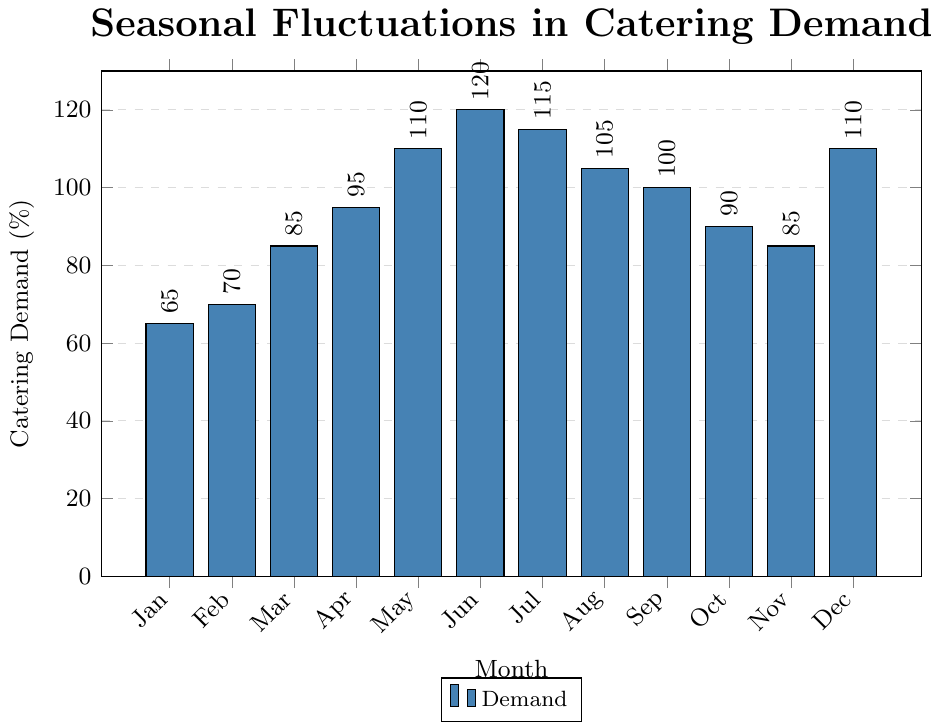What's the month with the highest catering demand? By looking at the highest bar in the chart, we see that June has the highest demand.
Answer: June Which month has the lowest catering demand? The smallest bar in the chart is for January, indicating the lowest demand.
Answer: January What is the increase in catering demand from January to June? The demand in January is 65%, and in June, it is 120%. The increase is calculated as 120% - 65%.
Answer: 55% What is the average catering demand in the first quarter (January, February, March)? The demands are 65% (January), 70% (February), and 85% (March). The average is calculated as (65 + 70 + 85) / 3.
Answer: 73.33% How much higher is the catering demand in July compared to October? In July, the demand is 115%, and in October, it is 90%. The difference is 115% - 90%.
Answer: 25% Which months have the same catering demand? By examining the heights of the bars, we can see that March and November both have a demand of 85%, and May and December both have a demand of 110%.
Answer: March and November, May and December What is the total catering demand for the summer months (June, July, August)? The demands are 120% (June), 115% (July), and 105% (August). The total is calculated as 120 + 115 + 105.
Answer: 340% Which month shows a demand closest to 100%? September has a demand of 100%, which is exactly 100%.
Answer: September In which quarter does the catering demand increase the most? The demands for each quarter are: Q1 (65%, 70%, 85%), Q2 (95%, 110%, 120%), Q3 (115%, 105%, 100%), Q4 (90%, 85%, 110%). The increase from Q1 to Q2 is the highest because the demand rises from 65% (January) to 120% (June).
Answer: Q2 Which two consecutive months have the biggest change in catering demand and what is the magnitude of the change? The largest change occurs between May (110%) and June (120%), which is calculated as 120% - 110%.
Answer: 10% 